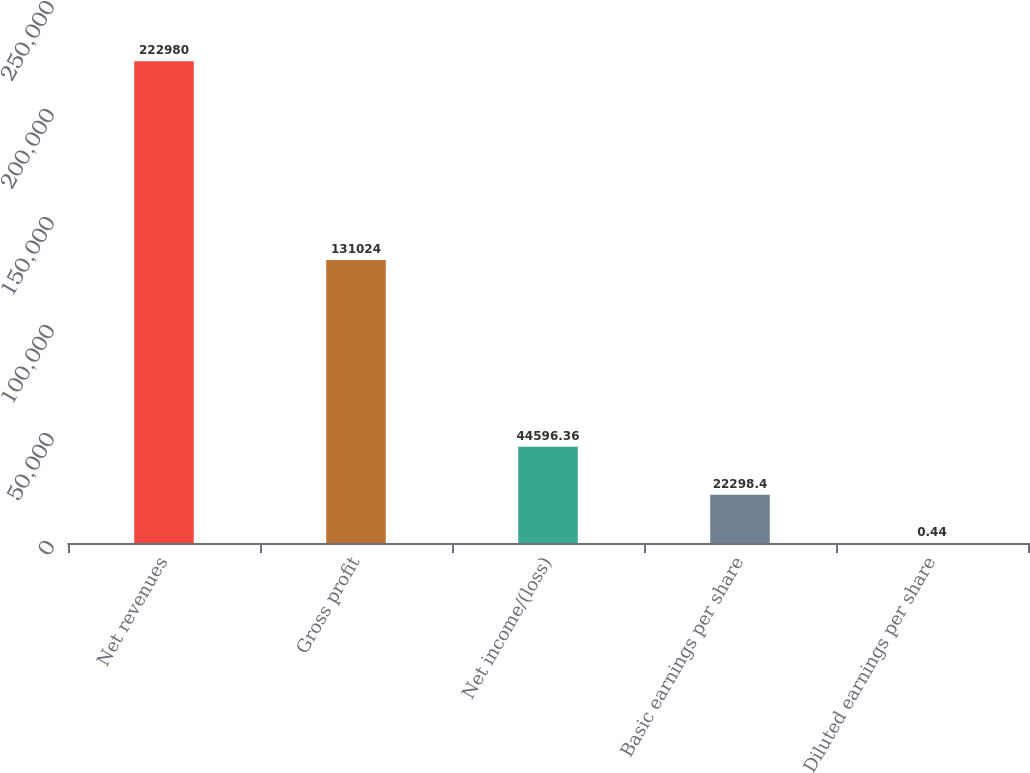Convert chart. <chart><loc_0><loc_0><loc_500><loc_500><bar_chart><fcel>Net revenues<fcel>Gross profit<fcel>Net income/(loss)<fcel>Basic earnings per share<fcel>Diluted earnings per share<nl><fcel>222980<fcel>131024<fcel>44596.4<fcel>22298.4<fcel>0.44<nl></chart> 